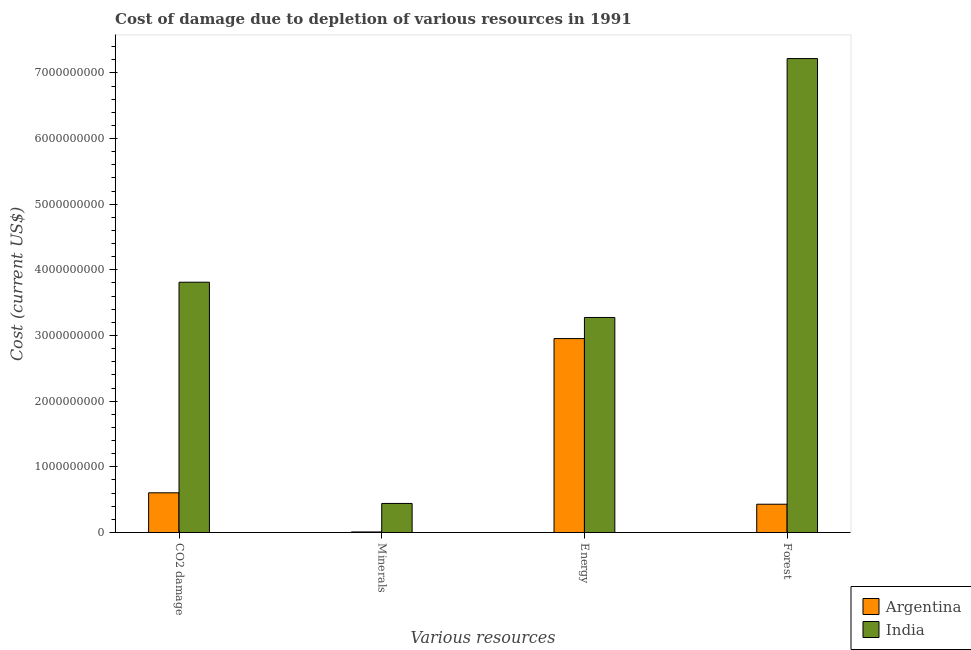How many groups of bars are there?
Offer a very short reply. 4. Are the number of bars per tick equal to the number of legend labels?
Give a very brief answer. Yes. What is the label of the 1st group of bars from the left?
Keep it short and to the point. CO2 damage. What is the cost of damage due to depletion of forests in Argentina?
Your response must be concise. 4.30e+08. Across all countries, what is the maximum cost of damage due to depletion of energy?
Your response must be concise. 3.27e+09. Across all countries, what is the minimum cost of damage due to depletion of forests?
Ensure brevity in your answer.  4.30e+08. In which country was the cost of damage due to depletion of coal minimum?
Give a very brief answer. Argentina. What is the total cost of damage due to depletion of energy in the graph?
Offer a very short reply. 6.23e+09. What is the difference between the cost of damage due to depletion of energy in India and that in Argentina?
Offer a terse response. 3.22e+08. What is the difference between the cost of damage due to depletion of energy in India and the cost of damage due to depletion of forests in Argentina?
Make the answer very short. 2.84e+09. What is the average cost of damage due to depletion of energy per country?
Give a very brief answer. 3.11e+09. What is the difference between the cost of damage due to depletion of energy and cost of damage due to depletion of forests in Argentina?
Your response must be concise. 2.52e+09. What is the ratio of the cost of damage due to depletion of forests in Argentina to that in India?
Ensure brevity in your answer.  0.06. Is the cost of damage due to depletion of forests in Argentina less than that in India?
Offer a terse response. Yes. What is the difference between the highest and the second highest cost of damage due to depletion of minerals?
Your response must be concise. 4.34e+08. What is the difference between the highest and the lowest cost of damage due to depletion of energy?
Provide a succinct answer. 3.22e+08. Is it the case that in every country, the sum of the cost of damage due to depletion of coal and cost of damage due to depletion of minerals is greater than the cost of damage due to depletion of energy?
Make the answer very short. No. How many bars are there?
Make the answer very short. 8. How many countries are there in the graph?
Provide a short and direct response. 2. Does the graph contain any zero values?
Ensure brevity in your answer.  No. Does the graph contain grids?
Your answer should be compact. No. How many legend labels are there?
Your answer should be very brief. 2. What is the title of the graph?
Your response must be concise. Cost of damage due to depletion of various resources in 1991 . What is the label or title of the X-axis?
Provide a short and direct response. Various resources. What is the label or title of the Y-axis?
Ensure brevity in your answer.  Cost (current US$). What is the Cost (current US$) of Argentina in CO2 damage?
Keep it short and to the point. 6.05e+08. What is the Cost (current US$) in India in CO2 damage?
Your response must be concise. 3.81e+09. What is the Cost (current US$) of Argentina in Minerals?
Ensure brevity in your answer.  8.34e+06. What is the Cost (current US$) in India in Minerals?
Ensure brevity in your answer.  4.42e+08. What is the Cost (current US$) in Argentina in Energy?
Provide a short and direct response. 2.95e+09. What is the Cost (current US$) in India in Energy?
Your response must be concise. 3.27e+09. What is the Cost (current US$) of Argentina in Forest?
Ensure brevity in your answer.  4.30e+08. What is the Cost (current US$) in India in Forest?
Give a very brief answer. 7.22e+09. Across all Various resources, what is the maximum Cost (current US$) in Argentina?
Your answer should be very brief. 2.95e+09. Across all Various resources, what is the maximum Cost (current US$) of India?
Provide a succinct answer. 7.22e+09. Across all Various resources, what is the minimum Cost (current US$) of Argentina?
Make the answer very short. 8.34e+06. Across all Various resources, what is the minimum Cost (current US$) in India?
Provide a succinct answer. 4.42e+08. What is the total Cost (current US$) of Argentina in the graph?
Offer a terse response. 4.00e+09. What is the total Cost (current US$) of India in the graph?
Your answer should be compact. 1.47e+1. What is the difference between the Cost (current US$) in Argentina in CO2 damage and that in Minerals?
Provide a short and direct response. 5.96e+08. What is the difference between the Cost (current US$) of India in CO2 damage and that in Minerals?
Provide a succinct answer. 3.37e+09. What is the difference between the Cost (current US$) in Argentina in CO2 damage and that in Energy?
Your answer should be compact. -2.35e+09. What is the difference between the Cost (current US$) in India in CO2 damage and that in Energy?
Provide a succinct answer. 5.37e+08. What is the difference between the Cost (current US$) of Argentina in CO2 damage and that in Forest?
Make the answer very short. 1.74e+08. What is the difference between the Cost (current US$) of India in CO2 damage and that in Forest?
Make the answer very short. -3.41e+09. What is the difference between the Cost (current US$) of Argentina in Minerals and that in Energy?
Offer a very short reply. -2.95e+09. What is the difference between the Cost (current US$) of India in Minerals and that in Energy?
Offer a terse response. -2.83e+09. What is the difference between the Cost (current US$) of Argentina in Minerals and that in Forest?
Offer a very short reply. -4.22e+08. What is the difference between the Cost (current US$) in India in Minerals and that in Forest?
Your response must be concise. -6.78e+09. What is the difference between the Cost (current US$) in Argentina in Energy and that in Forest?
Provide a short and direct response. 2.52e+09. What is the difference between the Cost (current US$) in India in Energy and that in Forest?
Your answer should be compact. -3.94e+09. What is the difference between the Cost (current US$) of Argentina in CO2 damage and the Cost (current US$) of India in Minerals?
Your answer should be compact. 1.62e+08. What is the difference between the Cost (current US$) in Argentina in CO2 damage and the Cost (current US$) in India in Energy?
Keep it short and to the point. -2.67e+09. What is the difference between the Cost (current US$) in Argentina in CO2 damage and the Cost (current US$) in India in Forest?
Your answer should be very brief. -6.61e+09. What is the difference between the Cost (current US$) of Argentina in Minerals and the Cost (current US$) of India in Energy?
Offer a very short reply. -3.27e+09. What is the difference between the Cost (current US$) in Argentina in Minerals and the Cost (current US$) in India in Forest?
Your response must be concise. -7.21e+09. What is the difference between the Cost (current US$) of Argentina in Energy and the Cost (current US$) of India in Forest?
Your answer should be compact. -4.26e+09. What is the average Cost (current US$) of Argentina per Various resources?
Keep it short and to the point. 9.99e+08. What is the average Cost (current US$) of India per Various resources?
Give a very brief answer. 3.69e+09. What is the difference between the Cost (current US$) of Argentina and Cost (current US$) of India in CO2 damage?
Make the answer very short. -3.21e+09. What is the difference between the Cost (current US$) in Argentina and Cost (current US$) in India in Minerals?
Ensure brevity in your answer.  -4.34e+08. What is the difference between the Cost (current US$) of Argentina and Cost (current US$) of India in Energy?
Provide a short and direct response. -3.22e+08. What is the difference between the Cost (current US$) in Argentina and Cost (current US$) in India in Forest?
Make the answer very short. -6.79e+09. What is the ratio of the Cost (current US$) in Argentina in CO2 damage to that in Minerals?
Offer a terse response. 72.5. What is the ratio of the Cost (current US$) of India in CO2 damage to that in Minerals?
Keep it short and to the point. 8.62. What is the ratio of the Cost (current US$) in Argentina in CO2 damage to that in Energy?
Your response must be concise. 0.2. What is the ratio of the Cost (current US$) in India in CO2 damage to that in Energy?
Your response must be concise. 1.16. What is the ratio of the Cost (current US$) of Argentina in CO2 damage to that in Forest?
Offer a terse response. 1.4. What is the ratio of the Cost (current US$) in India in CO2 damage to that in Forest?
Your answer should be very brief. 0.53. What is the ratio of the Cost (current US$) of Argentina in Minerals to that in Energy?
Your response must be concise. 0. What is the ratio of the Cost (current US$) in India in Minerals to that in Energy?
Give a very brief answer. 0.14. What is the ratio of the Cost (current US$) in Argentina in Minerals to that in Forest?
Give a very brief answer. 0.02. What is the ratio of the Cost (current US$) of India in Minerals to that in Forest?
Provide a succinct answer. 0.06. What is the ratio of the Cost (current US$) of Argentina in Energy to that in Forest?
Your answer should be very brief. 6.86. What is the ratio of the Cost (current US$) in India in Energy to that in Forest?
Provide a succinct answer. 0.45. What is the difference between the highest and the second highest Cost (current US$) of Argentina?
Give a very brief answer. 2.35e+09. What is the difference between the highest and the second highest Cost (current US$) in India?
Offer a terse response. 3.41e+09. What is the difference between the highest and the lowest Cost (current US$) of Argentina?
Your answer should be compact. 2.95e+09. What is the difference between the highest and the lowest Cost (current US$) of India?
Offer a very short reply. 6.78e+09. 